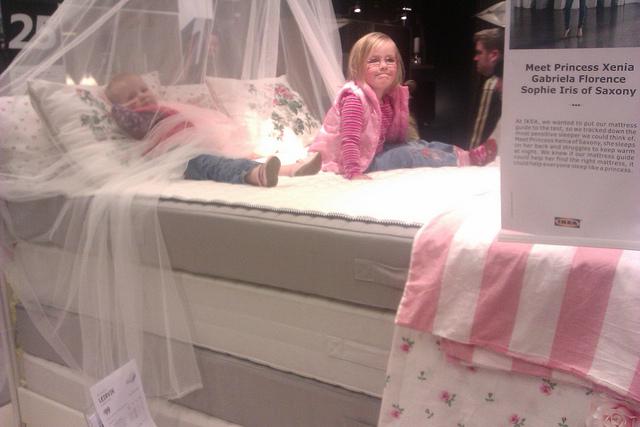Is this a princess bed?
Quick response, please. Yes. How many people are on the bed?
Give a very brief answer. 2. Are there more than 2 pillows on the bed?
Answer briefly. Yes. 